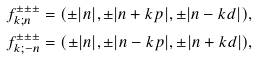<formula> <loc_0><loc_0><loc_500><loc_500>& f ^ { \pm \pm \pm } _ { k ; n } = ( \pm | n | , \pm | n + k p | , \pm | n - k d | ) , \\ & f ^ { \pm \pm \pm } _ { k ; - n } = ( \pm | n | , \pm | n - k p | , \pm | n + k d | ) ,</formula> 